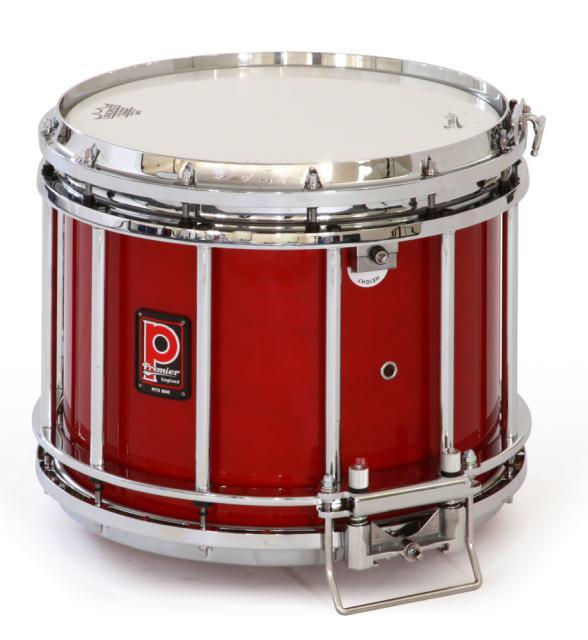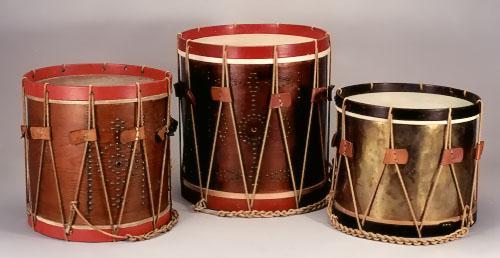The first image is the image on the left, the second image is the image on the right. For the images shown, is this caption "One image shows a single drum while the other shows drums along with other types of instruments." true? Answer yes or no. No. 